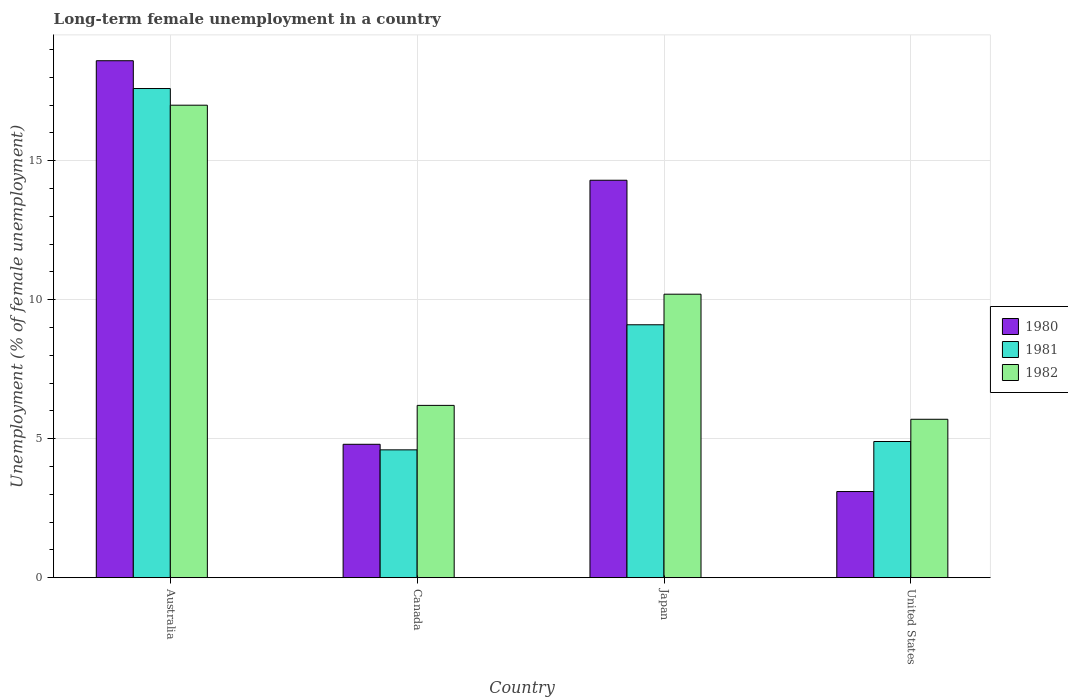How many different coloured bars are there?
Your response must be concise. 3. How many groups of bars are there?
Offer a terse response. 4. How many bars are there on the 3rd tick from the left?
Your response must be concise. 3. What is the label of the 1st group of bars from the left?
Offer a terse response. Australia. In how many cases, is the number of bars for a given country not equal to the number of legend labels?
Offer a very short reply. 0. What is the percentage of long-term unemployed female population in 1981 in Japan?
Offer a very short reply. 9.1. Across all countries, what is the minimum percentage of long-term unemployed female population in 1981?
Your response must be concise. 4.6. In which country was the percentage of long-term unemployed female population in 1981 maximum?
Keep it short and to the point. Australia. What is the total percentage of long-term unemployed female population in 1980 in the graph?
Make the answer very short. 40.8. What is the difference between the percentage of long-term unemployed female population in 1980 in Australia and that in Canada?
Make the answer very short. 13.8. What is the difference between the percentage of long-term unemployed female population in 1981 in Canada and the percentage of long-term unemployed female population in 1982 in United States?
Make the answer very short. -1.1. What is the average percentage of long-term unemployed female population in 1981 per country?
Provide a succinct answer. 9.05. What is the difference between the percentage of long-term unemployed female population of/in 1981 and percentage of long-term unemployed female population of/in 1982 in Canada?
Your answer should be very brief. -1.6. What is the ratio of the percentage of long-term unemployed female population in 1981 in Australia to that in United States?
Your answer should be very brief. 3.59. Is the percentage of long-term unemployed female population in 1981 in Canada less than that in Japan?
Offer a terse response. Yes. Is the difference between the percentage of long-term unemployed female population in 1981 in Australia and United States greater than the difference between the percentage of long-term unemployed female population in 1982 in Australia and United States?
Ensure brevity in your answer.  Yes. What is the difference between the highest and the second highest percentage of long-term unemployed female population in 1980?
Offer a very short reply. 13.8. What is the difference between the highest and the lowest percentage of long-term unemployed female population in 1980?
Your answer should be compact. 15.5. Is the sum of the percentage of long-term unemployed female population in 1980 in Australia and United States greater than the maximum percentage of long-term unemployed female population in 1982 across all countries?
Your answer should be very brief. Yes. What does the 1st bar from the left in Japan represents?
Your response must be concise. 1980. What does the 1st bar from the right in Australia represents?
Offer a very short reply. 1982. Are the values on the major ticks of Y-axis written in scientific E-notation?
Offer a very short reply. No. Does the graph contain any zero values?
Give a very brief answer. No. How many legend labels are there?
Your answer should be compact. 3. What is the title of the graph?
Provide a succinct answer. Long-term female unemployment in a country. Does "1972" appear as one of the legend labels in the graph?
Keep it short and to the point. No. What is the label or title of the X-axis?
Offer a very short reply. Country. What is the label or title of the Y-axis?
Your answer should be compact. Unemployment (% of female unemployment). What is the Unemployment (% of female unemployment) of 1980 in Australia?
Provide a succinct answer. 18.6. What is the Unemployment (% of female unemployment) of 1981 in Australia?
Give a very brief answer. 17.6. What is the Unemployment (% of female unemployment) of 1982 in Australia?
Your answer should be very brief. 17. What is the Unemployment (% of female unemployment) in 1980 in Canada?
Give a very brief answer. 4.8. What is the Unemployment (% of female unemployment) of 1981 in Canada?
Make the answer very short. 4.6. What is the Unemployment (% of female unemployment) of 1982 in Canada?
Your answer should be very brief. 6.2. What is the Unemployment (% of female unemployment) in 1980 in Japan?
Make the answer very short. 14.3. What is the Unemployment (% of female unemployment) in 1981 in Japan?
Give a very brief answer. 9.1. What is the Unemployment (% of female unemployment) in 1982 in Japan?
Provide a succinct answer. 10.2. What is the Unemployment (% of female unemployment) in 1980 in United States?
Provide a succinct answer. 3.1. What is the Unemployment (% of female unemployment) in 1981 in United States?
Provide a short and direct response. 4.9. What is the Unemployment (% of female unemployment) of 1982 in United States?
Make the answer very short. 5.7. Across all countries, what is the maximum Unemployment (% of female unemployment) of 1980?
Keep it short and to the point. 18.6. Across all countries, what is the maximum Unemployment (% of female unemployment) of 1981?
Provide a succinct answer. 17.6. Across all countries, what is the maximum Unemployment (% of female unemployment) of 1982?
Provide a short and direct response. 17. Across all countries, what is the minimum Unemployment (% of female unemployment) of 1980?
Your response must be concise. 3.1. Across all countries, what is the minimum Unemployment (% of female unemployment) in 1981?
Your answer should be very brief. 4.6. Across all countries, what is the minimum Unemployment (% of female unemployment) of 1982?
Ensure brevity in your answer.  5.7. What is the total Unemployment (% of female unemployment) in 1980 in the graph?
Keep it short and to the point. 40.8. What is the total Unemployment (% of female unemployment) in 1981 in the graph?
Provide a succinct answer. 36.2. What is the total Unemployment (% of female unemployment) in 1982 in the graph?
Ensure brevity in your answer.  39.1. What is the difference between the Unemployment (% of female unemployment) in 1980 in Australia and that in Canada?
Your answer should be very brief. 13.8. What is the difference between the Unemployment (% of female unemployment) of 1981 in Australia and that in Canada?
Keep it short and to the point. 13. What is the difference between the Unemployment (% of female unemployment) in 1980 in Australia and that in Japan?
Your answer should be very brief. 4.3. What is the difference between the Unemployment (% of female unemployment) in 1981 in Australia and that in Japan?
Provide a succinct answer. 8.5. What is the difference between the Unemployment (% of female unemployment) in 1980 in Australia and that in United States?
Ensure brevity in your answer.  15.5. What is the difference between the Unemployment (% of female unemployment) in 1982 in Canada and that in Japan?
Ensure brevity in your answer.  -4. What is the difference between the Unemployment (% of female unemployment) in 1980 in Japan and that in United States?
Give a very brief answer. 11.2. What is the difference between the Unemployment (% of female unemployment) of 1982 in Japan and that in United States?
Offer a terse response. 4.5. What is the difference between the Unemployment (% of female unemployment) in 1980 in Australia and the Unemployment (% of female unemployment) in 1982 in Canada?
Offer a very short reply. 12.4. What is the difference between the Unemployment (% of female unemployment) of 1981 in Australia and the Unemployment (% of female unemployment) of 1982 in Canada?
Ensure brevity in your answer.  11.4. What is the difference between the Unemployment (% of female unemployment) of 1980 in Australia and the Unemployment (% of female unemployment) of 1981 in Japan?
Offer a terse response. 9.5. What is the difference between the Unemployment (% of female unemployment) in 1980 in Australia and the Unemployment (% of female unemployment) in 1982 in Japan?
Ensure brevity in your answer.  8.4. What is the difference between the Unemployment (% of female unemployment) in 1981 in Australia and the Unemployment (% of female unemployment) in 1982 in Japan?
Keep it short and to the point. 7.4. What is the difference between the Unemployment (% of female unemployment) of 1980 in Australia and the Unemployment (% of female unemployment) of 1981 in United States?
Offer a terse response. 13.7. What is the difference between the Unemployment (% of female unemployment) in 1980 in Australia and the Unemployment (% of female unemployment) in 1982 in United States?
Offer a very short reply. 12.9. What is the difference between the Unemployment (% of female unemployment) of 1981 in Australia and the Unemployment (% of female unemployment) of 1982 in United States?
Offer a terse response. 11.9. What is the difference between the Unemployment (% of female unemployment) of 1980 in Canada and the Unemployment (% of female unemployment) of 1982 in Japan?
Offer a very short reply. -5.4. What is the difference between the Unemployment (% of female unemployment) of 1980 in Canada and the Unemployment (% of female unemployment) of 1982 in United States?
Make the answer very short. -0.9. What is the difference between the Unemployment (% of female unemployment) of 1980 in Japan and the Unemployment (% of female unemployment) of 1981 in United States?
Ensure brevity in your answer.  9.4. What is the average Unemployment (% of female unemployment) of 1981 per country?
Ensure brevity in your answer.  9.05. What is the average Unemployment (% of female unemployment) in 1982 per country?
Make the answer very short. 9.78. What is the difference between the Unemployment (% of female unemployment) of 1980 and Unemployment (% of female unemployment) of 1981 in Australia?
Offer a very short reply. 1. What is the difference between the Unemployment (% of female unemployment) of 1980 and Unemployment (% of female unemployment) of 1982 in Australia?
Keep it short and to the point. 1.6. What is the difference between the Unemployment (% of female unemployment) of 1981 and Unemployment (% of female unemployment) of 1982 in Australia?
Offer a terse response. 0.6. What is the difference between the Unemployment (% of female unemployment) of 1980 and Unemployment (% of female unemployment) of 1982 in Canada?
Your answer should be compact. -1.4. What is the difference between the Unemployment (% of female unemployment) in 1980 and Unemployment (% of female unemployment) in 1981 in Japan?
Your answer should be compact. 5.2. What is the difference between the Unemployment (% of female unemployment) in 1980 and Unemployment (% of female unemployment) in 1982 in Japan?
Give a very brief answer. 4.1. What is the difference between the Unemployment (% of female unemployment) in 1981 and Unemployment (% of female unemployment) in 1982 in Japan?
Ensure brevity in your answer.  -1.1. What is the difference between the Unemployment (% of female unemployment) of 1980 and Unemployment (% of female unemployment) of 1981 in United States?
Your answer should be very brief. -1.8. What is the difference between the Unemployment (% of female unemployment) of 1981 and Unemployment (% of female unemployment) of 1982 in United States?
Your response must be concise. -0.8. What is the ratio of the Unemployment (% of female unemployment) in 1980 in Australia to that in Canada?
Provide a succinct answer. 3.88. What is the ratio of the Unemployment (% of female unemployment) in 1981 in Australia to that in Canada?
Make the answer very short. 3.83. What is the ratio of the Unemployment (% of female unemployment) in 1982 in Australia to that in Canada?
Your answer should be very brief. 2.74. What is the ratio of the Unemployment (% of female unemployment) of 1980 in Australia to that in Japan?
Ensure brevity in your answer.  1.3. What is the ratio of the Unemployment (% of female unemployment) of 1981 in Australia to that in Japan?
Your answer should be compact. 1.93. What is the ratio of the Unemployment (% of female unemployment) of 1980 in Australia to that in United States?
Your answer should be very brief. 6. What is the ratio of the Unemployment (% of female unemployment) in 1981 in Australia to that in United States?
Ensure brevity in your answer.  3.59. What is the ratio of the Unemployment (% of female unemployment) in 1982 in Australia to that in United States?
Make the answer very short. 2.98. What is the ratio of the Unemployment (% of female unemployment) in 1980 in Canada to that in Japan?
Give a very brief answer. 0.34. What is the ratio of the Unemployment (% of female unemployment) in 1981 in Canada to that in Japan?
Provide a short and direct response. 0.51. What is the ratio of the Unemployment (% of female unemployment) of 1982 in Canada to that in Japan?
Provide a short and direct response. 0.61. What is the ratio of the Unemployment (% of female unemployment) of 1980 in Canada to that in United States?
Offer a terse response. 1.55. What is the ratio of the Unemployment (% of female unemployment) of 1981 in Canada to that in United States?
Your answer should be compact. 0.94. What is the ratio of the Unemployment (% of female unemployment) of 1982 in Canada to that in United States?
Your answer should be very brief. 1.09. What is the ratio of the Unemployment (% of female unemployment) of 1980 in Japan to that in United States?
Offer a terse response. 4.61. What is the ratio of the Unemployment (% of female unemployment) in 1981 in Japan to that in United States?
Give a very brief answer. 1.86. What is the ratio of the Unemployment (% of female unemployment) of 1982 in Japan to that in United States?
Ensure brevity in your answer.  1.79. What is the difference between the highest and the second highest Unemployment (% of female unemployment) of 1980?
Your response must be concise. 4.3. What is the difference between the highest and the second highest Unemployment (% of female unemployment) in 1982?
Your response must be concise. 6.8. What is the difference between the highest and the lowest Unemployment (% of female unemployment) in 1980?
Offer a terse response. 15.5. What is the difference between the highest and the lowest Unemployment (% of female unemployment) in 1981?
Offer a terse response. 13. What is the difference between the highest and the lowest Unemployment (% of female unemployment) in 1982?
Your answer should be compact. 11.3. 